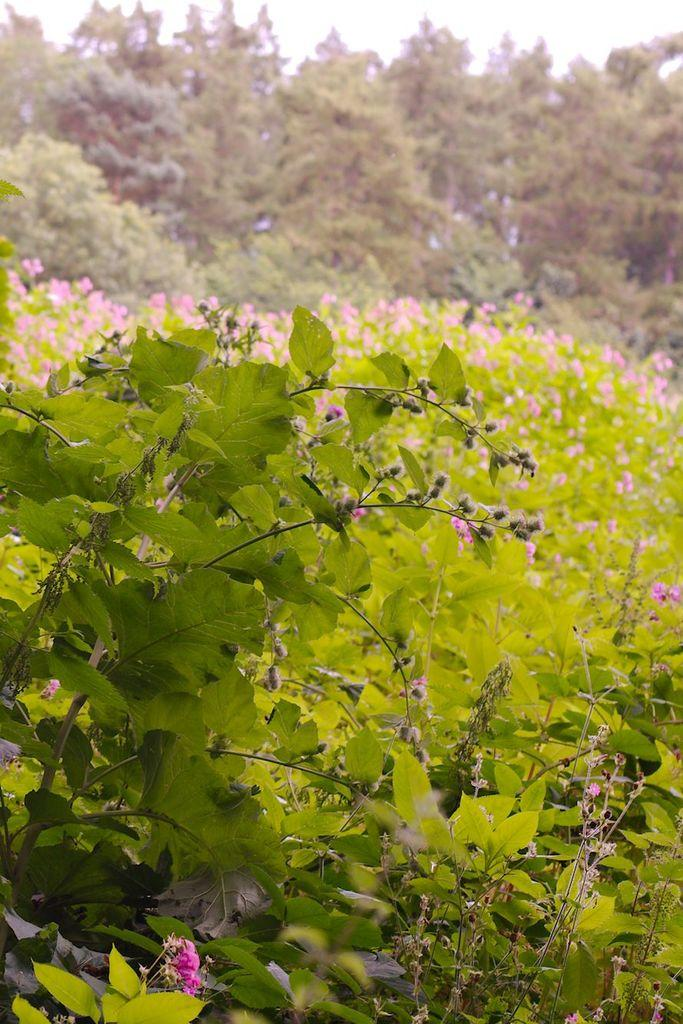What type of vegetation can be seen in the image? There are plants and trees in the image. Can you describe the trees in the image? The trees in the image are tall and have leaves. What type of cap can be seen on the sea in the image? There is no sea or cap present in the image; it features plants and trees. 